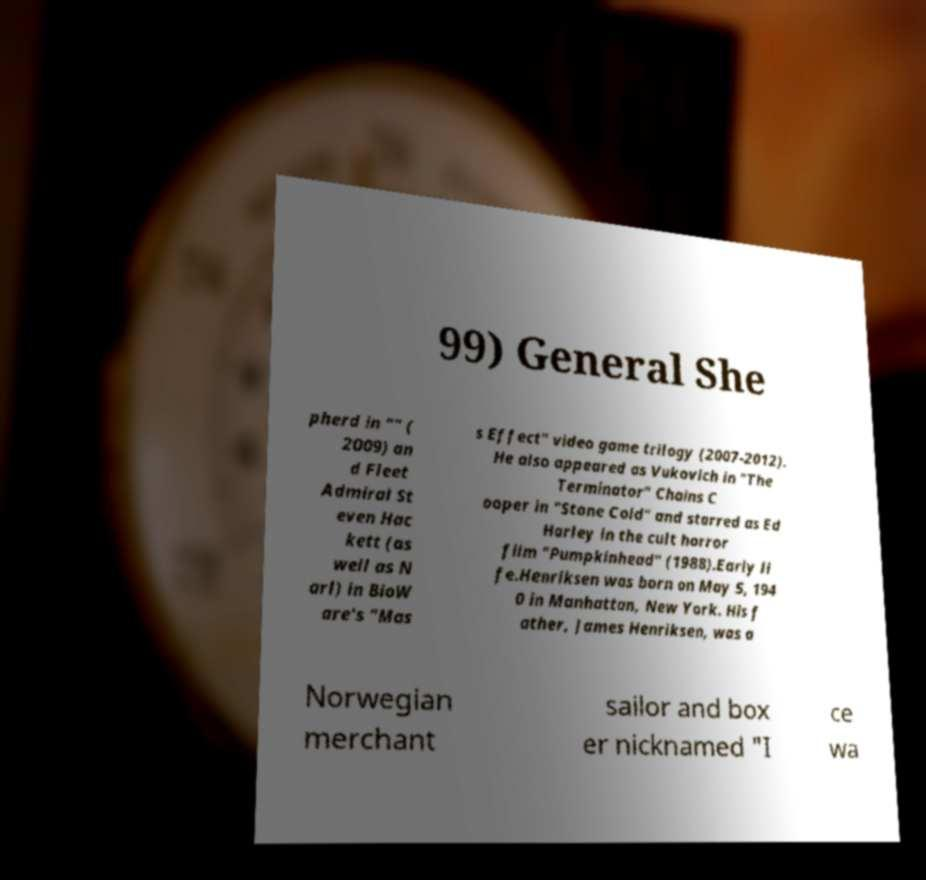For documentation purposes, I need the text within this image transcribed. Could you provide that? 99) General She pherd in "" ( 2009) an d Fleet Admiral St even Hac kett (as well as N arl) in BioW are's "Mas s Effect" video game trilogy (2007-2012). He also appeared as Vukovich in "The Terminator" Chains C ooper in "Stone Cold" and starred as Ed Harley in the cult horror film "Pumpkinhead" (1988).Early li fe.Henriksen was born on May 5, 194 0 in Manhattan, New York. His f ather, James Henriksen, was a Norwegian merchant sailor and box er nicknamed "I ce wa 